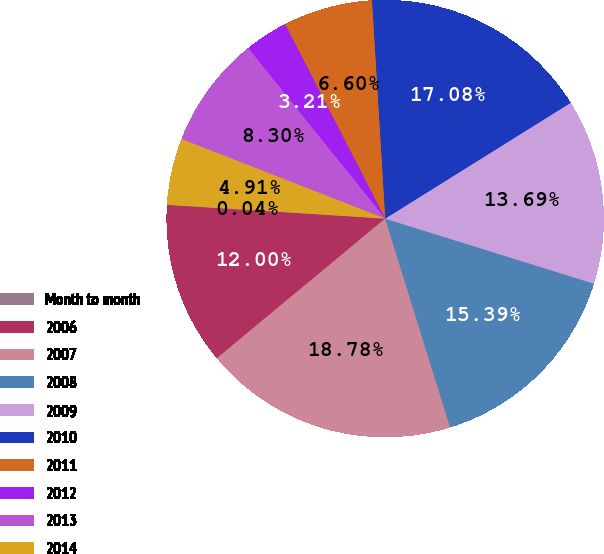Convert chart. <chart><loc_0><loc_0><loc_500><loc_500><pie_chart><fcel>Month to month<fcel>2006<fcel>2007<fcel>2008<fcel>2009<fcel>2010<fcel>2011<fcel>2012<fcel>2013<fcel>2014<nl><fcel>0.04%<fcel>12.0%<fcel>18.78%<fcel>15.39%<fcel>13.69%<fcel>17.08%<fcel>6.6%<fcel>3.21%<fcel>8.3%<fcel>4.91%<nl></chart> 